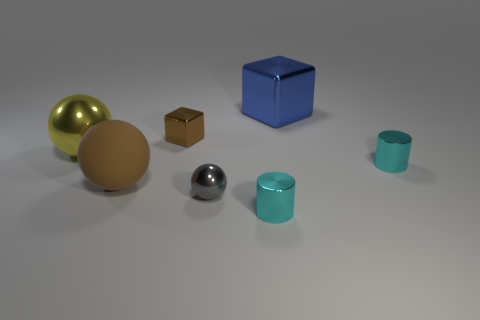Can you describe the colors and shapes of the objects in the image? Certainly! The image shows a collection of objects with varying colors and shapes. Starting from the left, there is a large shiny golden sphere, followed by a small brown cube. In the center, there’s a large solid blue cube. To the right, you’ll find a small shiny chrome sphere, and lastly, there is a small teal cylinder. 